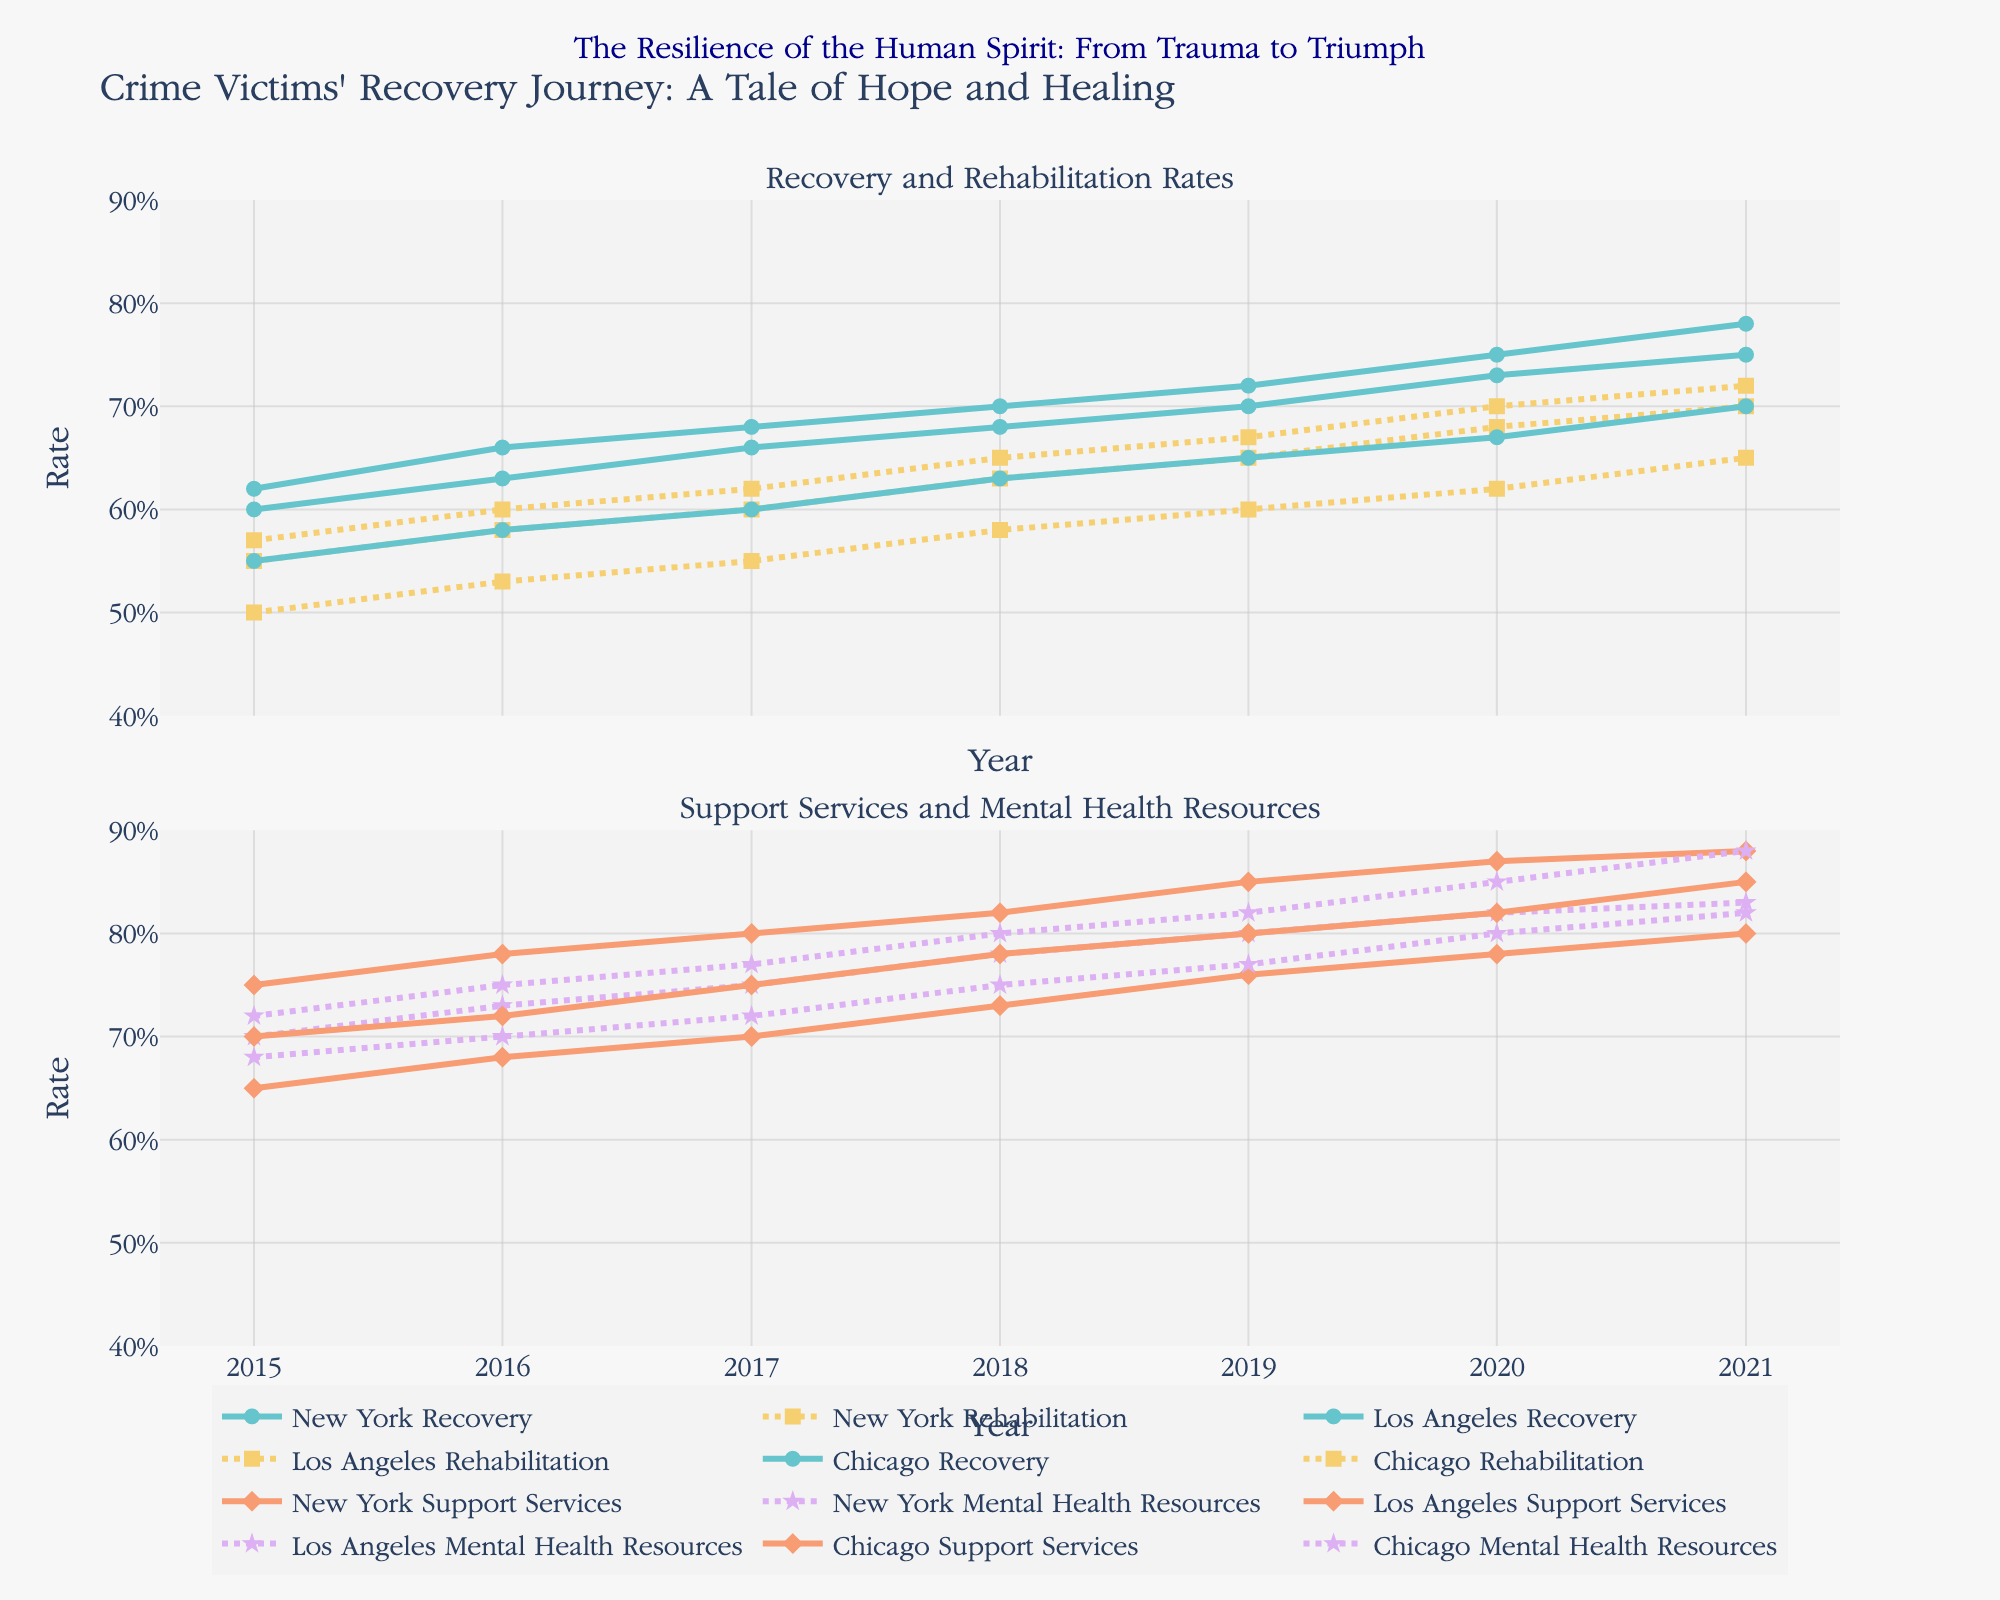What's the title of the figure? The title is located at the top of the figure and is clearly visible.
Answer: Crime Victims' Recovery Journey: A Tale of Hope and Healing Which city had the highest recovery rate in 2020? Look at the recovery rate traces for 2020 and compare the rates for New York, Los Angeles, and Chicago.
Answer: Chicago What is the trend for New York in terms of access to support services between 2015 and 2021? Follow the 'Support Services' trace for New York from 2015 to 2021. The trend shows a gradual increase each year.
Answer: Increasing Comparing the mental health resource quality in 2017, which city had the best provision? By comparing the Mental Health Resources Quality traces in 2017 for New York, Los Angeles, and Chicago, identify the highest one.
Answer: Chicago What are the average recovery and rehabilitation rates for Chicago over the given years? Sum the yearly values of the recovery and rehabilitation rates for Chicago and divide each by the number of years (7).
Answer: Recovery Rate: (0.62 + 0.66 + 0.68 + 0.70 + 0.72 + 0.75 + 0.78) / 7 = 0.70, Rehabilitation Rate: (0.57 + 0.60 + 0.62 + 0.65 + 0.67 + 0.70 + 0.72) / 7 = 0.65 Did access to support services improve for Los Angeles between 2019 and 2021? Look at the 'Support Services' trace for Los Angeles and compare the values between 2019 and 2021.
Answer: Yes How does the rehabilitation rate in New York in 2021 compare to 2015? Compare the values for the rehabilitation rate in New York in 2021 and 2015.
Answer: 2021 is higher Which city experienced the smallest increase in recovery rate between 2015 and 2021? Calculate the increase in recovery rate for each city and compare them: New York: 0.75 - 0.60 = 0.15, Los Angeles: 0.70 - 0.55 = 0.15, Chicago: 0.78 - 0.62 = 0.16.
Answer: Los Angeles What is the overall trend in mental health resources quality in Los Angeles from 2015 to 2021? Follow the 'Mental Health Resources Quality' trace for Los Angeles. The trend shows a steady increase each year.
Answer: Increasing Which year shows the highest recovery rate for any city? Look at all the recovery rate traces and identify the peak point for any city throughout the years.
Answer: 2021 for Chicago 